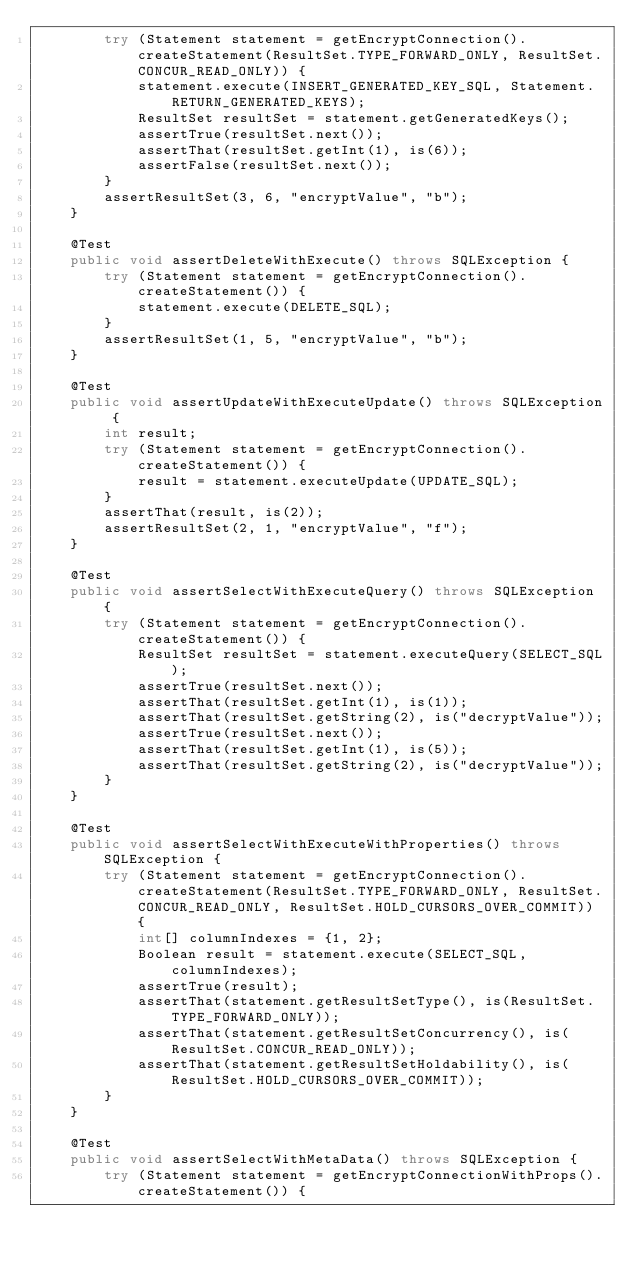<code> <loc_0><loc_0><loc_500><loc_500><_Java_>        try (Statement statement = getEncryptConnection().createStatement(ResultSet.TYPE_FORWARD_ONLY, ResultSet.CONCUR_READ_ONLY)) {
            statement.execute(INSERT_GENERATED_KEY_SQL, Statement.RETURN_GENERATED_KEYS);
            ResultSet resultSet = statement.getGeneratedKeys();
            assertTrue(resultSet.next());
            assertThat(resultSet.getInt(1), is(6));
            assertFalse(resultSet.next());
        }
        assertResultSet(3, 6, "encryptValue", "b");
    }
    
    @Test
    public void assertDeleteWithExecute() throws SQLException {
        try (Statement statement = getEncryptConnection().createStatement()) {
            statement.execute(DELETE_SQL);
        }
        assertResultSet(1, 5, "encryptValue", "b");
    }
    
    @Test
    public void assertUpdateWithExecuteUpdate() throws SQLException {
        int result;
        try (Statement statement = getEncryptConnection().createStatement()) {
            result = statement.executeUpdate(UPDATE_SQL);
        }
        assertThat(result, is(2));
        assertResultSet(2, 1, "encryptValue", "f");
    }
    
    @Test
    public void assertSelectWithExecuteQuery() throws SQLException {
        try (Statement statement = getEncryptConnection().createStatement()) {
            ResultSet resultSet = statement.executeQuery(SELECT_SQL);
            assertTrue(resultSet.next());
            assertThat(resultSet.getInt(1), is(1));
            assertThat(resultSet.getString(2), is("decryptValue"));
            assertTrue(resultSet.next());
            assertThat(resultSet.getInt(1), is(5));
            assertThat(resultSet.getString(2), is("decryptValue"));
        }
    }
    
    @Test
    public void assertSelectWithExecuteWithProperties() throws SQLException {
        try (Statement statement = getEncryptConnection().createStatement(ResultSet.TYPE_FORWARD_ONLY, ResultSet.CONCUR_READ_ONLY, ResultSet.HOLD_CURSORS_OVER_COMMIT)) {
            int[] columnIndexes = {1, 2};
            Boolean result = statement.execute(SELECT_SQL, columnIndexes);
            assertTrue(result);
            assertThat(statement.getResultSetType(), is(ResultSet.TYPE_FORWARD_ONLY));
            assertThat(statement.getResultSetConcurrency(), is(ResultSet.CONCUR_READ_ONLY));
            assertThat(statement.getResultSetHoldability(), is(ResultSet.HOLD_CURSORS_OVER_COMMIT));
        }
    }
    
    @Test
    public void assertSelectWithMetaData() throws SQLException {
        try (Statement statement = getEncryptConnectionWithProps().createStatement()) {</code> 